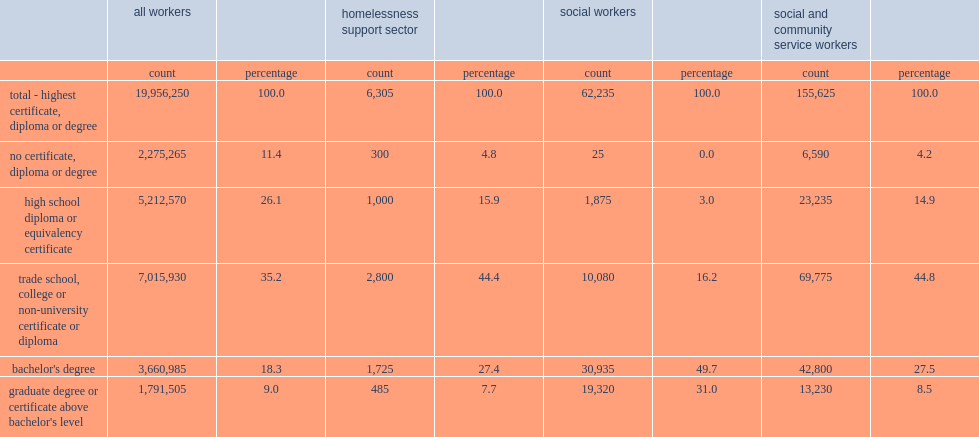What was the proportion of homelessness support sector workers that obtained a trade school, college or non-university certificate or diploma? 44.4. What was the proportion of homelessness support sector workers that earned a bachelor's degree? 27.4. What was the proportion of social workers that had a bachelor's degree? 49.7. What was the proportion of social workers that had a graduate degree or certificate above the bachelor's level? 31.0. 